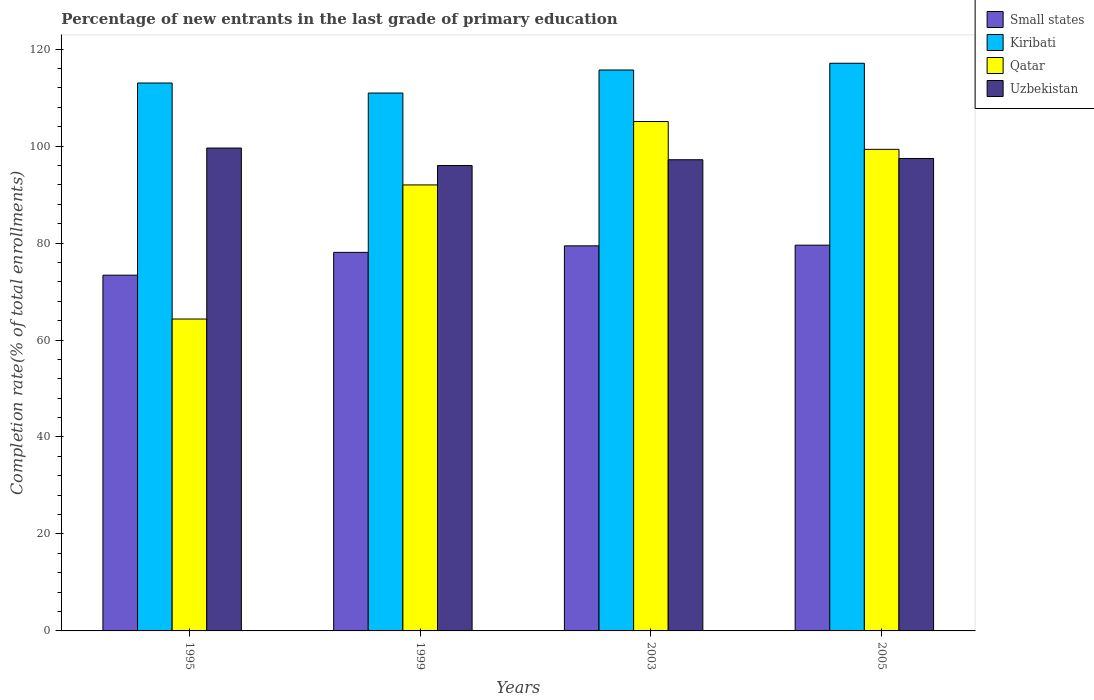How many different coloured bars are there?
Your response must be concise. 4. How many bars are there on the 1st tick from the left?
Your answer should be compact. 4. What is the percentage of new entrants in Small states in 2003?
Provide a succinct answer. 79.42. Across all years, what is the maximum percentage of new entrants in Qatar?
Your response must be concise. 105.06. Across all years, what is the minimum percentage of new entrants in Small states?
Ensure brevity in your answer.  73.37. In which year was the percentage of new entrants in Kiribati maximum?
Ensure brevity in your answer.  2005. In which year was the percentage of new entrants in Qatar minimum?
Your response must be concise. 1995. What is the total percentage of new entrants in Qatar in the graph?
Give a very brief answer. 360.69. What is the difference between the percentage of new entrants in Uzbekistan in 2003 and that in 2005?
Offer a terse response. -0.26. What is the difference between the percentage of new entrants in Kiribati in 1999 and the percentage of new entrants in Qatar in 1995?
Keep it short and to the point. 46.61. What is the average percentage of new entrants in Small states per year?
Offer a very short reply. 77.61. In the year 1999, what is the difference between the percentage of new entrants in Uzbekistan and percentage of new entrants in Small states?
Offer a very short reply. 17.92. In how many years, is the percentage of new entrants in Qatar greater than 108 %?
Make the answer very short. 0. What is the ratio of the percentage of new entrants in Kiribati in 1999 to that in 2003?
Provide a short and direct response. 0.96. Is the percentage of new entrants in Uzbekistan in 1995 less than that in 2005?
Provide a short and direct response. No. Is the difference between the percentage of new entrants in Uzbekistan in 1995 and 2003 greater than the difference between the percentage of new entrants in Small states in 1995 and 2003?
Ensure brevity in your answer.  Yes. What is the difference between the highest and the second highest percentage of new entrants in Qatar?
Make the answer very short. 5.74. What is the difference between the highest and the lowest percentage of new entrants in Kiribati?
Ensure brevity in your answer.  6.14. Is the sum of the percentage of new entrants in Small states in 1995 and 2003 greater than the maximum percentage of new entrants in Kiribati across all years?
Your answer should be compact. Yes. What does the 3rd bar from the left in 2005 represents?
Your response must be concise. Qatar. What does the 2nd bar from the right in 1995 represents?
Offer a terse response. Qatar. How many bars are there?
Make the answer very short. 16. How many years are there in the graph?
Offer a very short reply. 4. Does the graph contain any zero values?
Offer a very short reply. No. Does the graph contain grids?
Keep it short and to the point. No. How many legend labels are there?
Your response must be concise. 4. How are the legend labels stacked?
Give a very brief answer. Vertical. What is the title of the graph?
Offer a very short reply. Percentage of new entrants in the last grade of primary education. What is the label or title of the X-axis?
Your response must be concise. Years. What is the label or title of the Y-axis?
Your answer should be very brief. Completion rate(% of total enrollments). What is the Completion rate(% of total enrollments) in Small states in 1995?
Give a very brief answer. 73.37. What is the Completion rate(% of total enrollments) in Kiribati in 1995?
Make the answer very short. 113. What is the Completion rate(% of total enrollments) of Qatar in 1995?
Make the answer very short. 64.33. What is the Completion rate(% of total enrollments) in Uzbekistan in 1995?
Offer a very short reply. 99.59. What is the Completion rate(% of total enrollments) of Small states in 1999?
Provide a succinct answer. 78.07. What is the Completion rate(% of total enrollments) in Kiribati in 1999?
Your answer should be very brief. 110.94. What is the Completion rate(% of total enrollments) of Qatar in 1999?
Provide a succinct answer. 91.98. What is the Completion rate(% of total enrollments) in Uzbekistan in 1999?
Your answer should be compact. 95.99. What is the Completion rate(% of total enrollments) of Small states in 2003?
Keep it short and to the point. 79.42. What is the Completion rate(% of total enrollments) in Kiribati in 2003?
Give a very brief answer. 115.69. What is the Completion rate(% of total enrollments) of Qatar in 2003?
Keep it short and to the point. 105.06. What is the Completion rate(% of total enrollments) of Uzbekistan in 2003?
Keep it short and to the point. 97.18. What is the Completion rate(% of total enrollments) of Small states in 2005?
Provide a succinct answer. 79.56. What is the Completion rate(% of total enrollments) of Kiribati in 2005?
Keep it short and to the point. 117.08. What is the Completion rate(% of total enrollments) in Qatar in 2005?
Your response must be concise. 99.32. What is the Completion rate(% of total enrollments) in Uzbekistan in 2005?
Your response must be concise. 97.44. Across all years, what is the maximum Completion rate(% of total enrollments) in Small states?
Your answer should be compact. 79.56. Across all years, what is the maximum Completion rate(% of total enrollments) in Kiribati?
Offer a very short reply. 117.08. Across all years, what is the maximum Completion rate(% of total enrollments) of Qatar?
Your response must be concise. 105.06. Across all years, what is the maximum Completion rate(% of total enrollments) in Uzbekistan?
Make the answer very short. 99.59. Across all years, what is the minimum Completion rate(% of total enrollments) in Small states?
Provide a short and direct response. 73.37. Across all years, what is the minimum Completion rate(% of total enrollments) of Kiribati?
Provide a short and direct response. 110.94. Across all years, what is the minimum Completion rate(% of total enrollments) in Qatar?
Your response must be concise. 64.33. Across all years, what is the minimum Completion rate(% of total enrollments) of Uzbekistan?
Keep it short and to the point. 95.99. What is the total Completion rate(% of total enrollments) of Small states in the graph?
Your response must be concise. 310.42. What is the total Completion rate(% of total enrollments) in Kiribati in the graph?
Give a very brief answer. 456.71. What is the total Completion rate(% of total enrollments) in Qatar in the graph?
Provide a succinct answer. 360.69. What is the total Completion rate(% of total enrollments) of Uzbekistan in the graph?
Offer a very short reply. 390.2. What is the difference between the Completion rate(% of total enrollments) in Small states in 1995 and that in 1999?
Offer a very short reply. -4.7. What is the difference between the Completion rate(% of total enrollments) of Kiribati in 1995 and that in 1999?
Provide a short and direct response. 2.07. What is the difference between the Completion rate(% of total enrollments) of Qatar in 1995 and that in 1999?
Offer a very short reply. -27.66. What is the difference between the Completion rate(% of total enrollments) in Uzbekistan in 1995 and that in 1999?
Offer a very short reply. 3.6. What is the difference between the Completion rate(% of total enrollments) of Small states in 1995 and that in 2003?
Give a very brief answer. -6.05. What is the difference between the Completion rate(% of total enrollments) in Kiribati in 1995 and that in 2003?
Keep it short and to the point. -2.68. What is the difference between the Completion rate(% of total enrollments) of Qatar in 1995 and that in 2003?
Your response must be concise. -40.73. What is the difference between the Completion rate(% of total enrollments) in Uzbekistan in 1995 and that in 2003?
Give a very brief answer. 2.41. What is the difference between the Completion rate(% of total enrollments) of Small states in 1995 and that in 2005?
Keep it short and to the point. -6.19. What is the difference between the Completion rate(% of total enrollments) in Kiribati in 1995 and that in 2005?
Keep it short and to the point. -4.07. What is the difference between the Completion rate(% of total enrollments) of Qatar in 1995 and that in 2005?
Your answer should be very brief. -35. What is the difference between the Completion rate(% of total enrollments) in Uzbekistan in 1995 and that in 2005?
Your answer should be compact. 2.15. What is the difference between the Completion rate(% of total enrollments) of Small states in 1999 and that in 2003?
Your answer should be very brief. -1.35. What is the difference between the Completion rate(% of total enrollments) of Kiribati in 1999 and that in 2003?
Provide a short and direct response. -4.75. What is the difference between the Completion rate(% of total enrollments) in Qatar in 1999 and that in 2003?
Your response must be concise. -13.08. What is the difference between the Completion rate(% of total enrollments) of Uzbekistan in 1999 and that in 2003?
Your answer should be compact. -1.19. What is the difference between the Completion rate(% of total enrollments) in Small states in 1999 and that in 2005?
Your answer should be very brief. -1.49. What is the difference between the Completion rate(% of total enrollments) in Kiribati in 1999 and that in 2005?
Give a very brief answer. -6.14. What is the difference between the Completion rate(% of total enrollments) of Qatar in 1999 and that in 2005?
Your answer should be compact. -7.34. What is the difference between the Completion rate(% of total enrollments) in Uzbekistan in 1999 and that in 2005?
Ensure brevity in your answer.  -1.45. What is the difference between the Completion rate(% of total enrollments) in Small states in 2003 and that in 2005?
Provide a short and direct response. -0.14. What is the difference between the Completion rate(% of total enrollments) of Kiribati in 2003 and that in 2005?
Ensure brevity in your answer.  -1.39. What is the difference between the Completion rate(% of total enrollments) of Qatar in 2003 and that in 2005?
Offer a very short reply. 5.74. What is the difference between the Completion rate(% of total enrollments) in Uzbekistan in 2003 and that in 2005?
Ensure brevity in your answer.  -0.26. What is the difference between the Completion rate(% of total enrollments) in Small states in 1995 and the Completion rate(% of total enrollments) in Kiribati in 1999?
Give a very brief answer. -37.57. What is the difference between the Completion rate(% of total enrollments) in Small states in 1995 and the Completion rate(% of total enrollments) in Qatar in 1999?
Provide a short and direct response. -18.61. What is the difference between the Completion rate(% of total enrollments) in Small states in 1995 and the Completion rate(% of total enrollments) in Uzbekistan in 1999?
Your answer should be very brief. -22.62. What is the difference between the Completion rate(% of total enrollments) in Kiribati in 1995 and the Completion rate(% of total enrollments) in Qatar in 1999?
Your answer should be compact. 21.02. What is the difference between the Completion rate(% of total enrollments) in Kiribati in 1995 and the Completion rate(% of total enrollments) in Uzbekistan in 1999?
Your answer should be compact. 17.02. What is the difference between the Completion rate(% of total enrollments) of Qatar in 1995 and the Completion rate(% of total enrollments) of Uzbekistan in 1999?
Your answer should be compact. -31.66. What is the difference between the Completion rate(% of total enrollments) in Small states in 1995 and the Completion rate(% of total enrollments) in Kiribati in 2003?
Provide a succinct answer. -42.32. What is the difference between the Completion rate(% of total enrollments) in Small states in 1995 and the Completion rate(% of total enrollments) in Qatar in 2003?
Provide a succinct answer. -31.69. What is the difference between the Completion rate(% of total enrollments) of Small states in 1995 and the Completion rate(% of total enrollments) of Uzbekistan in 2003?
Offer a very short reply. -23.81. What is the difference between the Completion rate(% of total enrollments) of Kiribati in 1995 and the Completion rate(% of total enrollments) of Qatar in 2003?
Provide a succinct answer. 7.94. What is the difference between the Completion rate(% of total enrollments) in Kiribati in 1995 and the Completion rate(% of total enrollments) in Uzbekistan in 2003?
Provide a short and direct response. 15.83. What is the difference between the Completion rate(% of total enrollments) of Qatar in 1995 and the Completion rate(% of total enrollments) of Uzbekistan in 2003?
Provide a short and direct response. -32.85. What is the difference between the Completion rate(% of total enrollments) of Small states in 1995 and the Completion rate(% of total enrollments) of Kiribati in 2005?
Offer a terse response. -43.71. What is the difference between the Completion rate(% of total enrollments) in Small states in 1995 and the Completion rate(% of total enrollments) in Qatar in 2005?
Give a very brief answer. -25.95. What is the difference between the Completion rate(% of total enrollments) in Small states in 1995 and the Completion rate(% of total enrollments) in Uzbekistan in 2005?
Keep it short and to the point. -24.07. What is the difference between the Completion rate(% of total enrollments) of Kiribati in 1995 and the Completion rate(% of total enrollments) of Qatar in 2005?
Offer a terse response. 13.68. What is the difference between the Completion rate(% of total enrollments) in Kiribati in 1995 and the Completion rate(% of total enrollments) in Uzbekistan in 2005?
Provide a short and direct response. 15.57. What is the difference between the Completion rate(% of total enrollments) of Qatar in 1995 and the Completion rate(% of total enrollments) of Uzbekistan in 2005?
Your response must be concise. -33.11. What is the difference between the Completion rate(% of total enrollments) of Small states in 1999 and the Completion rate(% of total enrollments) of Kiribati in 2003?
Ensure brevity in your answer.  -37.62. What is the difference between the Completion rate(% of total enrollments) of Small states in 1999 and the Completion rate(% of total enrollments) of Qatar in 2003?
Provide a short and direct response. -26.99. What is the difference between the Completion rate(% of total enrollments) of Small states in 1999 and the Completion rate(% of total enrollments) of Uzbekistan in 2003?
Make the answer very short. -19.11. What is the difference between the Completion rate(% of total enrollments) of Kiribati in 1999 and the Completion rate(% of total enrollments) of Qatar in 2003?
Provide a succinct answer. 5.88. What is the difference between the Completion rate(% of total enrollments) in Kiribati in 1999 and the Completion rate(% of total enrollments) in Uzbekistan in 2003?
Provide a succinct answer. 13.76. What is the difference between the Completion rate(% of total enrollments) in Qatar in 1999 and the Completion rate(% of total enrollments) in Uzbekistan in 2003?
Offer a very short reply. -5.19. What is the difference between the Completion rate(% of total enrollments) of Small states in 1999 and the Completion rate(% of total enrollments) of Kiribati in 2005?
Offer a very short reply. -39. What is the difference between the Completion rate(% of total enrollments) of Small states in 1999 and the Completion rate(% of total enrollments) of Qatar in 2005?
Give a very brief answer. -21.25. What is the difference between the Completion rate(% of total enrollments) in Small states in 1999 and the Completion rate(% of total enrollments) in Uzbekistan in 2005?
Offer a very short reply. -19.37. What is the difference between the Completion rate(% of total enrollments) of Kiribati in 1999 and the Completion rate(% of total enrollments) of Qatar in 2005?
Offer a terse response. 11.61. What is the difference between the Completion rate(% of total enrollments) in Kiribati in 1999 and the Completion rate(% of total enrollments) in Uzbekistan in 2005?
Offer a terse response. 13.5. What is the difference between the Completion rate(% of total enrollments) in Qatar in 1999 and the Completion rate(% of total enrollments) in Uzbekistan in 2005?
Provide a succinct answer. -5.46. What is the difference between the Completion rate(% of total enrollments) of Small states in 2003 and the Completion rate(% of total enrollments) of Kiribati in 2005?
Your response must be concise. -37.66. What is the difference between the Completion rate(% of total enrollments) of Small states in 2003 and the Completion rate(% of total enrollments) of Qatar in 2005?
Make the answer very short. -19.9. What is the difference between the Completion rate(% of total enrollments) of Small states in 2003 and the Completion rate(% of total enrollments) of Uzbekistan in 2005?
Your answer should be very brief. -18.02. What is the difference between the Completion rate(% of total enrollments) of Kiribati in 2003 and the Completion rate(% of total enrollments) of Qatar in 2005?
Your response must be concise. 16.37. What is the difference between the Completion rate(% of total enrollments) of Kiribati in 2003 and the Completion rate(% of total enrollments) of Uzbekistan in 2005?
Provide a short and direct response. 18.25. What is the difference between the Completion rate(% of total enrollments) in Qatar in 2003 and the Completion rate(% of total enrollments) in Uzbekistan in 2005?
Offer a very short reply. 7.62. What is the average Completion rate(% of total enrollments) in Small states per year?
Offer a terse response. 77.61. What is the average Completion rate(% of total enrollments) of Kiribati per year?
Your answer should be compact. 114.18. What is the average Completion rate(% of total enrollments) of Qatar per year?
Give a very brief answer. 90.17. What is the average Completion rate(% of total enrollments) in Uzbekistan per year?
Your answer should be very brief. 97.55. In the year 1995, what is the difference between the Completion rate(% of total enrollments) of Small states and Completion rate(% of total enrollments) of Kiribati?
Provide a succinct answer. -39.64. In the year 1995, what is the difference between the Completion rate(% of total enrollments) in Small states and Completion rate(% of total enrollments) in Qatar?
Your answer should be very brief. 9.04. In the year 1995, what is the difference between the Completion rate(% of total enrollments) of Small states and Completion rate(% of total enrollments) of Uzbekistan?
Give a very brief answer. -26.22. In the year 1995, what is the difference between the Completion rate(% of total enrollments) of Kiribati and Completion rate(% of total enrollments) of Qatar?
Provide a succinct answer. 48.68. In the year 1995, what is the difference between the Completion rate(% of total enrollments) of Kiribati and Completion rate(% of total enrollments) of Uzbekistan?
Give a very brief answer. 13.41. In the year 1995, what is the difference between the Completion rate(% of total enrollments) in Qatar and Completion rate(% of total enrollments) in Uzbekistan?
Offer a very short reply. -35.26. In the year 1999, what is the difference between the Completion rate(% of total enrollments) of Small states and Completion rate(% of total enrollments) of Kiribati?
Your answer should be very brief. -32.86. In the year 1999, what is the difference between the Completion rate(% of total enrollments) of Small states and Completion rate(% of total enrollments) of Qatar?
Offer a terse response. -13.91. In the year 1999, what is the difference between the Completion rate(% of total enrollments) in Small states and Completion rate(% of total enrollments) in Uzbekistan?
Provide a short and direct response. -17.92. In the year 1999, what is the difference between the Completion rate(% of total enrollments) of Kiribati and Completion rate(% of total enrollments) of Qatar?
Make the answer very short. 18.95. In the year 1999, what is the difference between the Completion rate(% of total enrollments) of Kiribati and Completion rate(% of total enrollments) of Uzbekistan?
Offer a terse response. 14.95. In the year 1999, what is the difference between the Completion rate(% of total enrollments) in Qatar and Completion rate(% of total enrollments) in Uzbekistan?
Give a very brief answer. -4.01. In the year 2003, what is the difference between the Completion rate(% of total enrollments) of Small states and Completion rate(% of total enrollments) of Kiribati?
Make the answer very short. -36.27. In the year 2003, what is the difference between the Completion rate(% of total enrollments) in Small states and Completion rate(% of total enrollments) in Qatar?
Offer a very short reply. -25.64. In the year 2003, what is the difference between the Completion rate(% of total enrollments) in Small states and Completion rate(% of total enrollments) in Uzbekistan?
Your response must be concise. -17.76. In the year 2003, what is the difference between the Completion rate(% of total enrollments) in Kiribati and Completion rate(% of total enrollments) in Qatar?
Make the answer very short. 10.63. In the year 2003, what is the difference between the Completion rate(% of total enrollments) of Kiribati and Completion rate(% of total enrollments) of Uzbekistan?
Keep it short and to the point. 18.51. In the year 2003, what is the difference between the Completion rate(% of total enrollments) of Qatar and Completion rate(% of total enrollments) of Uzbekistan?
Ensure brevity in your answer.  7.88. In the year 2005, what is the difference between the Completion rate(% of total enrollments) in Small states and Completion rate(% of total enrollments) in Kiribati?
Give a very brief answer. -37.52. In the year 2005, what is the difference between the Completion rate(% of total enrollments) of Small states and Completion rate(% of total enrollments) of Qatar?
Your response must be concise. -19.76. In the year 2005, what is the difference between the Completion rate(% of total enrollments) in Small states and Completion rate(% of total enrollments) in Uzbekistan?
Ensure brevity in your answer.  -17.88. In the year 2005, what is the difference between the Completion rate(% of total enrollments) of Kiribati and Completion rate(% of total enrollments) of Qatar?
Ensure brevity in your answer.  17.76. In the year 2005, what is the difference between the Completion rate(% of total enrollments) of Kiribati and Completion rate(% of total enrollments) of Uzbekistan?
Provide a short and direct response. 19.64. In the year 2005, what is the difference between the Completion rate(% of total enrollments) of Qatar and Completion rate(% of total enrollments) of Uzbekistan?
Provide a succinct answer. 1.88. What is the ratio of the Completion rate(% of total enrollments) of Small states in 1995 to that in 1999?
Give a very brief answer. 0.94. What is the ratio of the Completion rate(% of total enrollments) of Kiribati in 1995 to that in 1999?
Keep it short and to the point. 1.02. What is the ratio of the Completion rate(% of total enrollments) in Qatar in 1995 to that in 1999?
Give a very brief answer. 0.7. What is the ratio of the Completion rate(% of total enrollments) in Uzbekistan in 1995 to that in 1999?
Make the answer very short. 1.04. What is the ratio of the Completion rate(% of total enrollments) of Small states in 1995 to that in 2003?
Keep it short and to the point. 0.92. What is the ratio of the Completion rate(% of total enrollments) in Kiribati in 1995 to that in 2003?
Ensure brevity in your answer.  0.98. What is the ratio of the Completion rate(% of total enrollments) of Qatar in 1995 to that in 2003?
Your answer should be very brief. 0.61. What is the ratio of the Completion rate(% of total enrollments) in Uzbekistan in 1995 to that in 2003?
Your answer should be very brief. 1.02. What is the ratio of the Completion rate(% of total enrollments) in Small states in 1995 to that in 2005?
Keep it short and to the point. 0.92. What is the ratio of the Completion rate(% of total enrollments) in Kiribati in 1995 to that in 2005?
Provide a succinct answer. 0.97. What is the ratio of the Completion rate(% of total enrollments) of Qatar in 1995 to that in 2005?
Give a very brief answer. 0.65. What is the ratio of the Completion rate(% of total enrollments) in Uzbekistan in 1995 to that in 2005?
Keep it short and to the point. 1.02. What is the ratio of the Completion rate(% of total enrollments) in Kiribati in 1999 to that in 2003?
Offer a very short reply. 0.96. What is the ratio of the Completion rate(% of total enrollments) of Qatar in 1999 to that in 2003?
Your answer should be compact. 0.88. What is the ratio of the Completion rate(% of total enrollments) in Small states in 1999 to that in 2005?
Your answer should be compact. 0.98. What is the ratio of the Completion rate(% of total enrollments) in Kiribati in 1999 to that in 2005?
Your answer should be compact. 0.95. What is the ratio of the Completion rate(% of total enrollments) in Qatar in 1999 to that in 2005?
Provide a short and direct response. 0.93. What is the ratio of the Completion rate(% of total enrollments) of Uzbekistan in 1999 to that in 2005?
Provide a short and direct response. 0.99. What is the ratio of the Completion rate(% of total enrollments) of Small states in 2003 to that in 2005?
Offer a very short reply. 1. What is the ratio of the Completion rate(% of total enrollments) in Kiribati in 2003 to that in 2005?
Provide a succinct answer. 0.99. What is the ratio of the Completion rate(% of total enrollments) in Qatar in 2003 to that in 2005?
Give a very brief answer. 1.06. What is the ratio of the Completion rate(% of total enrollments) in Uzbekistan in 2003 to that in 2005?
Give a very brief answer. 1. What is the difference between the highest and the second highest Completion rate(% of total enrollments) of Small states?
Keep it short and to the point. 0.14. What is the difference between the highest and the second highest Completion rate(% of total enrollments) in Kiribati?
Provide a short and direct response. 1.39. What is the difference between the highest and the second highest Completion rate(% of total enrollments) in Qatar?
Provide a succinct answer. 5.74. What is the difference between the highest and the second highest Completion rate(% of total enrollments) in Uzbekistan?
Give a very brief answer. 2.15. What is the difference between the highest and the lowest Completion rate(% of total enrollments) in Small states?
Provide a succinct answer. 6.19. What is the difference between the highest and the lowest Completion rate(% of total enrollments) in Kiribati?
Provide a succinct answer. 6.14. What is the difference between the highest and the lowest Completion rate(% of total enrollments) of Qatar?
Provide a short and direct response. 40.73. What is the difference between the highest and the lowest Completion rate(% of total enrollments) in Uzbekistan?
Give a very brief answer. 3.6. 